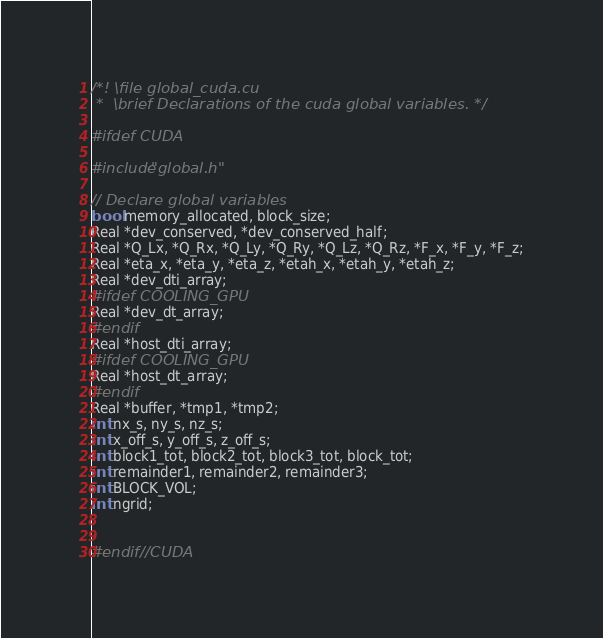Convert code to text. <code><loc_0><loc_0><loc_500><loc_500><_Cuda_>/*! \file global_cuda.cu
 *  \brief Declarations of the cuda global variables. */

#ifdef CUDA

#include"global.h"

// Declare global variables
bool memory_allocated, block_size;
Real *dev_conserved, *dev_conserved_half;
Real *Q_Lx, *Q_Rx, *Q_Ly, *Q_Ry, *Q_Lz, *Q_Rz, *F_x, *F_y, *F_z;
Real *eta_x, *eta_y, *eta_z, *etah_x, *etah_y, *etah_z;
Real *dev_dti_array;
#ifdef COOLING_GPU
Real *dev_dt_array;
#endif
Real *host_dti_array;
#ifdef COOLING_GPU
Real *host_dt_array;
#endif
Real *buffer, *tmp1, *tmp2;
int nx_s, ny_s, nz_s;
int x_off_s, y_off_s, z_off_s;
int block1_tot, block2_tot, block3_tot, block_tot;
int remainder1, remainder2, remainder3;
int BLOCK_VOL;
int ngrid;


#endif //CUDA
</code> 